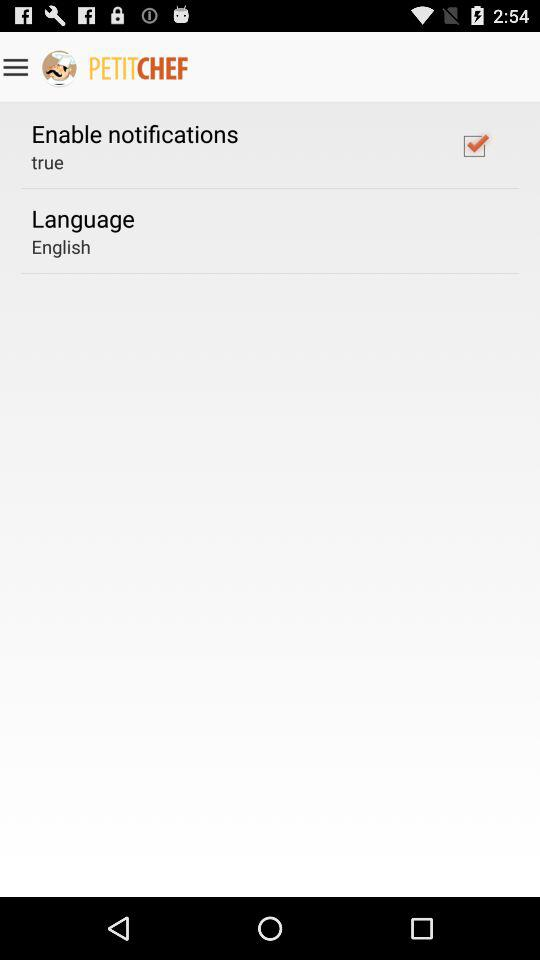Is "Enable notifications" true or false? "Enable notifications" is true. 